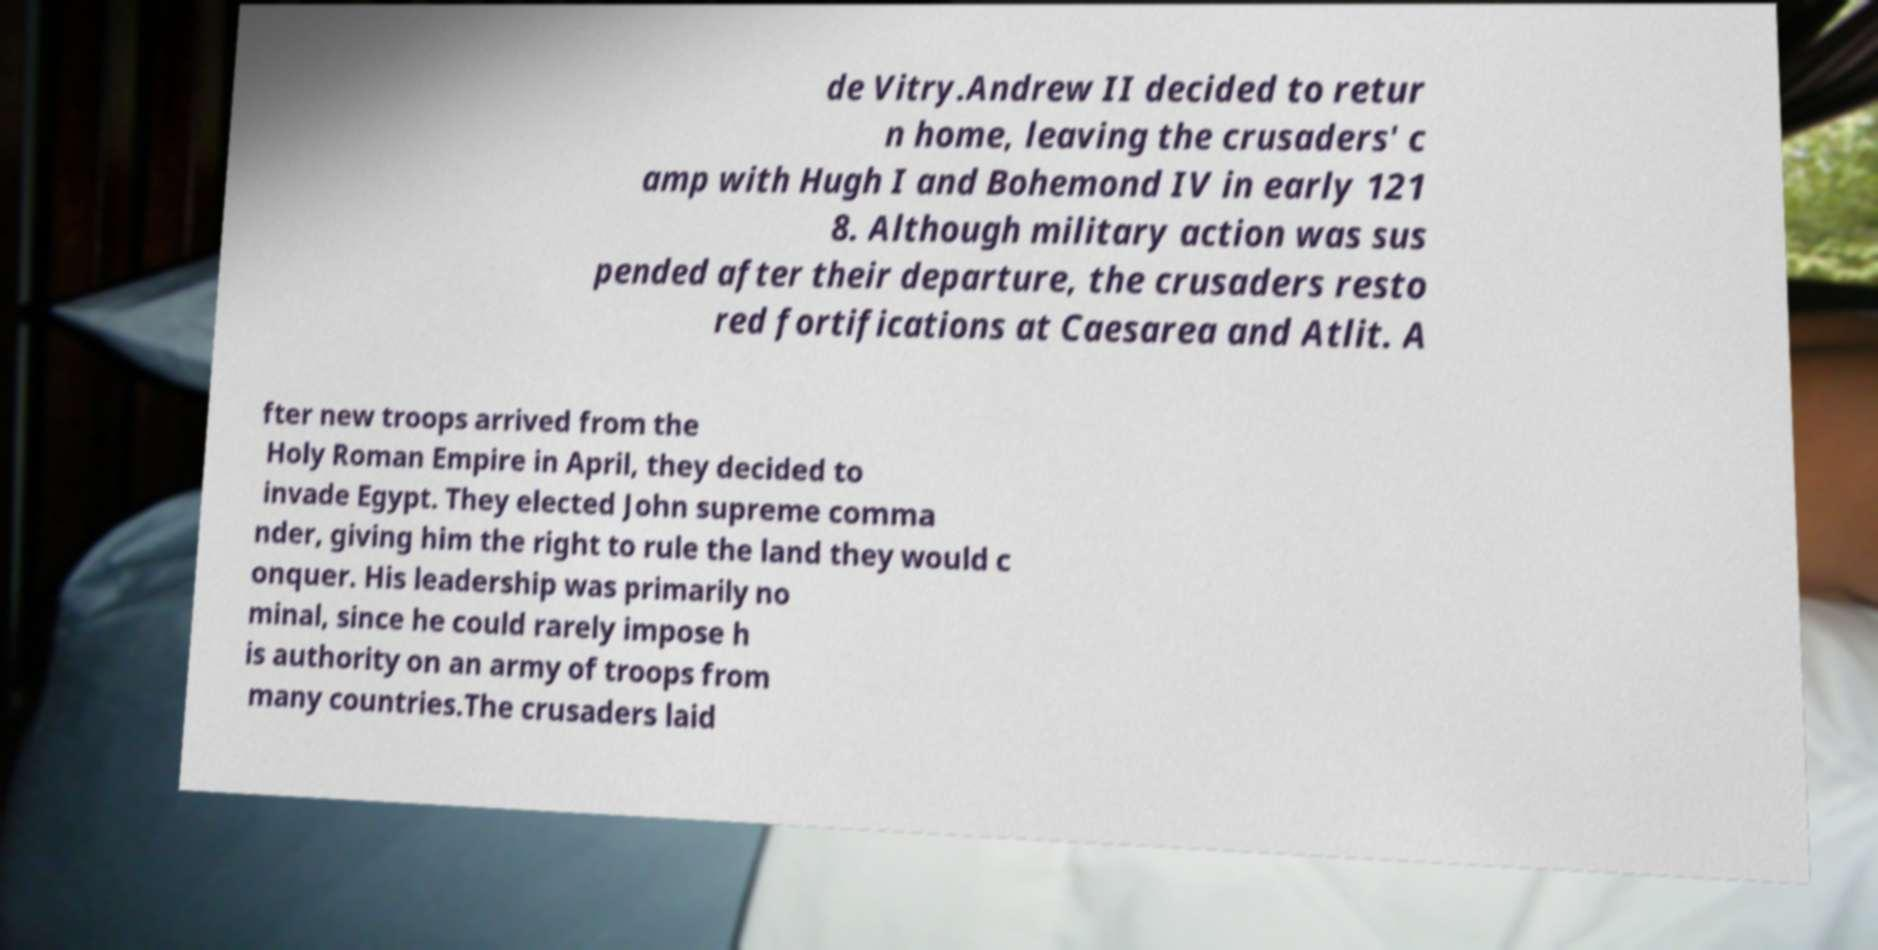Can you read and provide the text displayed in the image?This photo seems to have some interesting text. Can you extract and type it out for me? de Vitry.Andrew II decided to retur n home, leaving the crusaders' c amp with Hugh I and Bohemond IV in early 121 8. Although military action was sus pended after their departure, the crusaders resto red fortifications at Caesarea and Atlit. A fter new troops arrived from the Holy Roman Empire in April, they decided to invade Egypt. They elected John supreme comma nder, giving him the right to rule the land they would c onquer. His leadership was primarily no minal, since he could rarely impose h is authority on an army of troops from many countries.The crusaders laid 